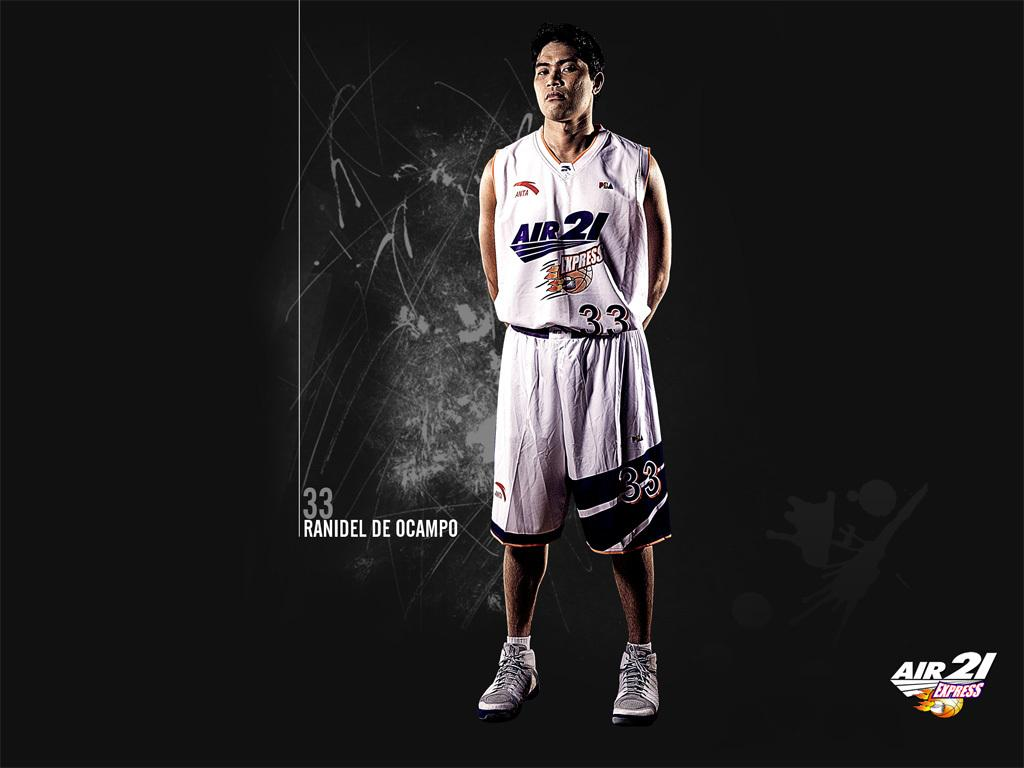<image>
Provide a brief description of the given image. Ranidel De Ocampo stands in his full number 33 kit. 